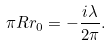<formula> <loc_0><loc_0><loc_500><loc_500>\pi R r _ { 0 } = - \frac { i \lambda } { 2 \pi } .</formula> 